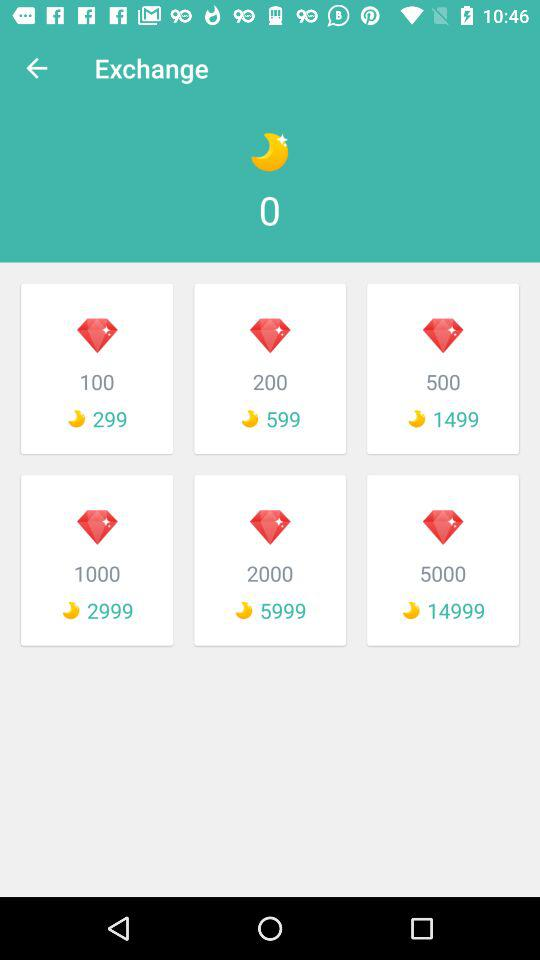How many diamonds can be exchanged for 599 moons' worth? The number of diamonds that can be exchanged for 599 moons' worth is 200. 